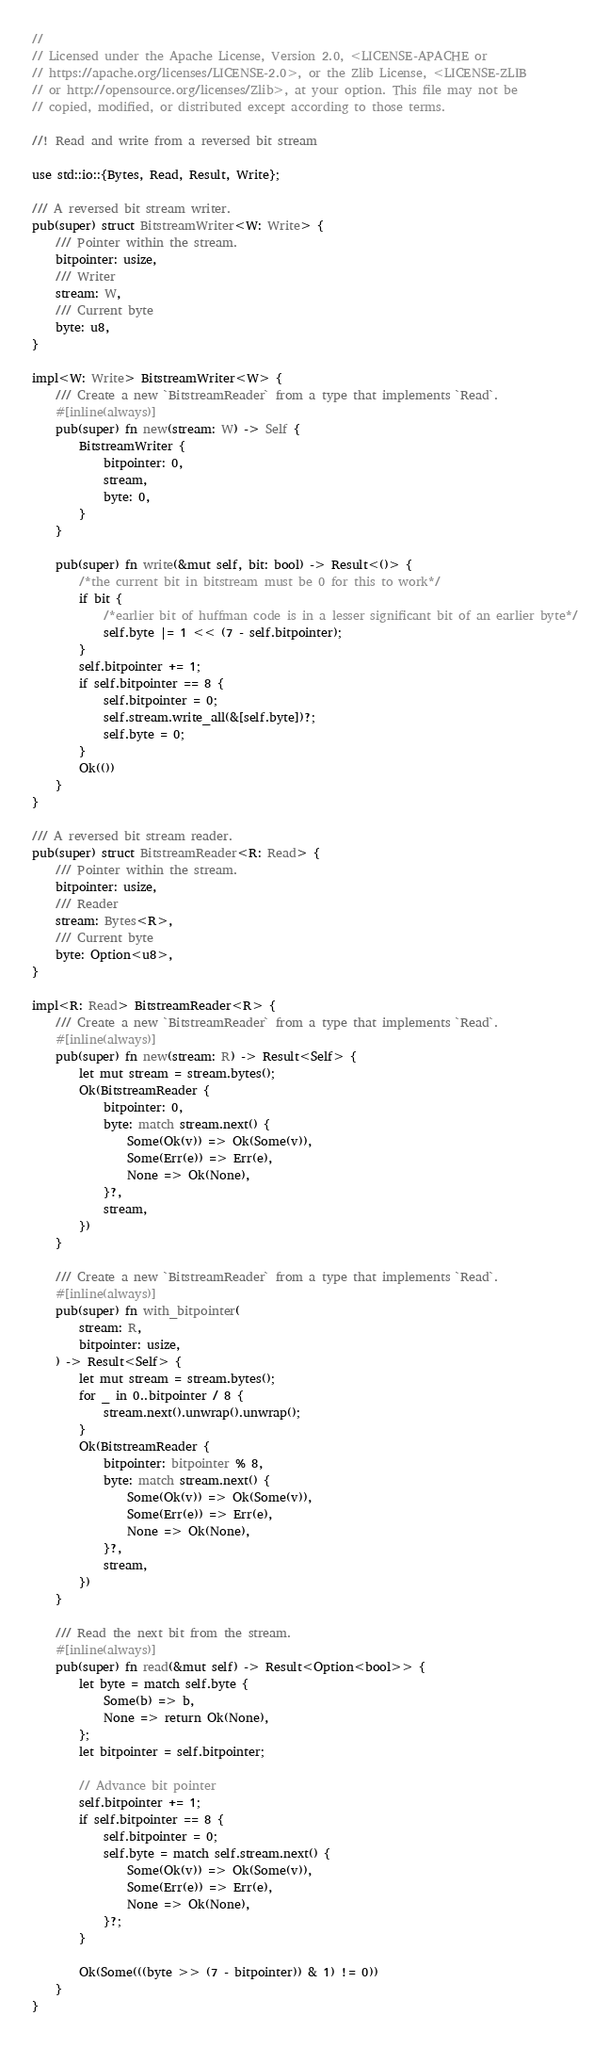Convert code to text. <code><loc_0><loc_0><loc_500><loc_500><_Rust_>//
// Licensed under the Apache License, Version 2.0, <LICENSE-APACHE or
// https://apache.org/licenses/LICENSE-2.0>, or the Zlib License, <LICENSE-ZLIB
// or http://opensource.org/licenses/Zlib>, at your option. This file may not be
// copied, modified, or distributed except according to those terms.

//! Read and write from a reversed bit stream

use std::io::{Bytes, Read, Result, Write};

/// A reversed bit stream writer.
pub(super) struct BitstreamWriter<W: Write> {
    /// Pointer within the stream.
    bitpointer: usize,
    /// Writer
    stream: W,
    /// Current byte
    byte: u8,
}

impl<W: Write> BitstreamWriter<W> {
    /// Create a new `BitstreamReader` from a type that implements `Read`.
    #[inline(always)]
    pub(super) fn new(stream: W) -> Self {
        BitstreamWriter {
            bitpointer: 0,
            stream,
            byte: 0,
        }
    }

    pub(super) fn write(&mut self, bit: bool) -> Result<()> {
        /*the current bit in bitstream must be 0 for this to work*/
        if bit {
            /*earlier bit of huffman code is in a lesser significant bit of an earlier byte*/
            self.byte |= 1 << (7 - self.bitpointer);
        }
        self.bitpointer += 1;
        if self.bitpointer == 8 {
            self.bitpointer = 0;
            self.stream.write_all(&[self.byte])?;
            self.byte = 0;
        }
        Ok(())
    }
}

/// A reversed bit stream reader.
pub(super) struct BitstreamReader<R: Read> {
    /// Pointer within the stream.
    bitpointer: usize,
    /// Reader
    stream: Bytes<R>,
    /// Current byte
    byte: Option<u8>,
}

impl<R: Read> BitstreamReader<R> {
    /// Create a new `BitstreamReader` from a type that implements `Read`.
    #[inline(always)]
    pub(super) fn new(stream: R) -> Result<Self> {
        let mut stream = stream.bytes();
        Ok(BitstreamReader {
            bitpointer: 0,
            byte: match stream.next() {
                Some(Ok(v)) => Ok(Some(v)),
                Some(Err(e)) => Err(e),
                None => Ok(None),
            }?,
            stream,
        })
    }

    /// Create a new `BitstreamReader` from a type that implements `Read`.
    #[inline(always)]
    pub(super) fn with_bitpointer(
        stream: R,
        bitpointer: usize,
    ) -> Result<Self> {
        let mut stream = stream.bytes();
        for _ in 0..bitpointer / 8 {
            stream.next().unwrap().unwrap();
        }
        Ok(BitstreamReader {
            bitpointer: bitpointer % 8,
            byte: match stream.next() {
                Some(Ok(v)) => Ok(Some(v)),
                Some(Err(e)) => Err(e),
                None => Ok(None),
            }?,
            stream,
        })
    }

    /// Read the next bit from the stream.
    #[inline(always)]
    pub(super) fn read(&mut self) -> Result<Option<bool>> {
        let byte = match self.byte {
            Some(b) => b,
            None => return Ok(None),
        };
        let bitpointer = self.bitpointer;

        // Advance bit pointer
        self.bitpointer += 1;
        if self.bitpointer == 8 {
            self.bitpointer = 0;
            self.byte = match self.stream.next() {
                Some(Ok(v)) => Ok(Some(v)),
                Some(Err(e)) => Err(e),
                None => Ok(None),
            }?;
        }

        Ok(Some(((byte >> (7 - bitpointer)) & 1) != 0))
    }
}
</code> 